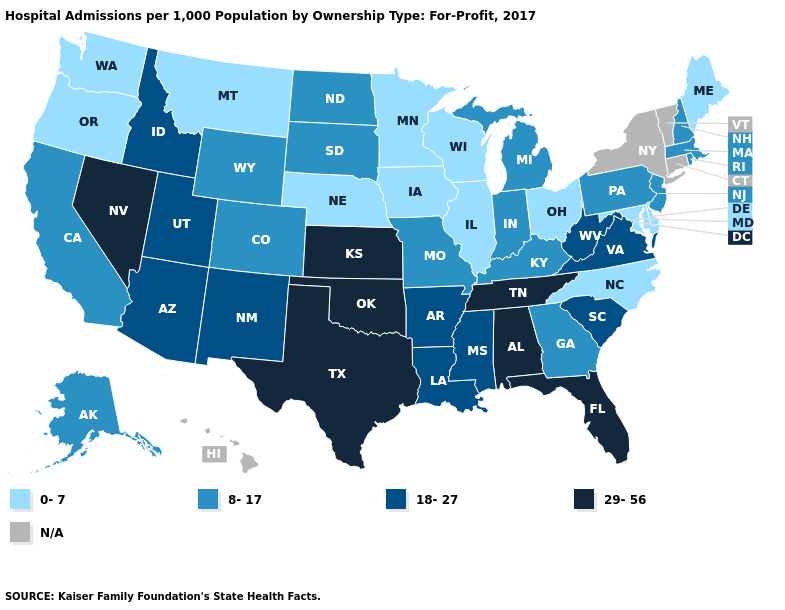What is the value of Ohio?
Give a very brief answer. 0-7. Name the states that have a value in the range 0-7?
Keep it brief. Delaware, Illinois, Iowa, Maine, Maryland, Minnesota, Montana, Nebraska, North Carolina, Ohio, Oregon, Washington, Wisconsin. What is the value of Nebraska?
Write a very short answer. 0-7. Name the states that have a value in the range 18-27?
Write a very short answer. Arizona, Arkansas, Idaho, Louisiana, Mississippi, New Mexico, South Carolina, Utah, Virginia, West Virginia. Does Nevada have the highest value in the West?
Write a very short answer. Yes. Name the states that have a value in the range 18-27?
Write a very short answer. Arizona, Arkansas, Idaho, Louisiana, Mississippi, New Mexico, South Carolina, Utah, Virginia, West Virginia. What is the lowest value in the West?
Short answer required. 0-7. Does Wisconsin have the lowest value in the USA?
Concise answer only. Yes. Name the states that have a value in the range 18-27?
Quick response, please. Arizona, Arkansas, Idaho, Louisiana, Mississippi, New Mexico, South Carolina, Utah, Virginia, West Virginia. What is the value of Montana?
Answer briefly. 0-7. Which states have the highest value in the USA?
Write a very short answer. Alabama, Florida, Kansas, Nevada, Oklahoma, Tennessee, Texas. What is the highest value in states that border Wyoming?
Quick response, please. 18-27. What is the highest value in the USA?
Be succinct. 29-56. What is the lowest value in the USA?
Quick response, please. 0-7. Does Kansas have the highest value in the USA?
Write a very short answer. Yes. 